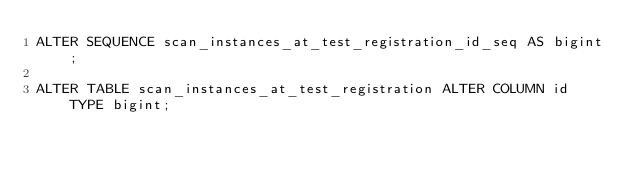<code> <loc_0><loc_0><loc_500><loc_500><_SQL_>ALTER SEQUENCE scan_instances_at_test_registration_id_seq AS bigint;

ALTER TABLE scan_instances_at_test_registration ALTER COLUMN id TYPE bigint;

</code> 